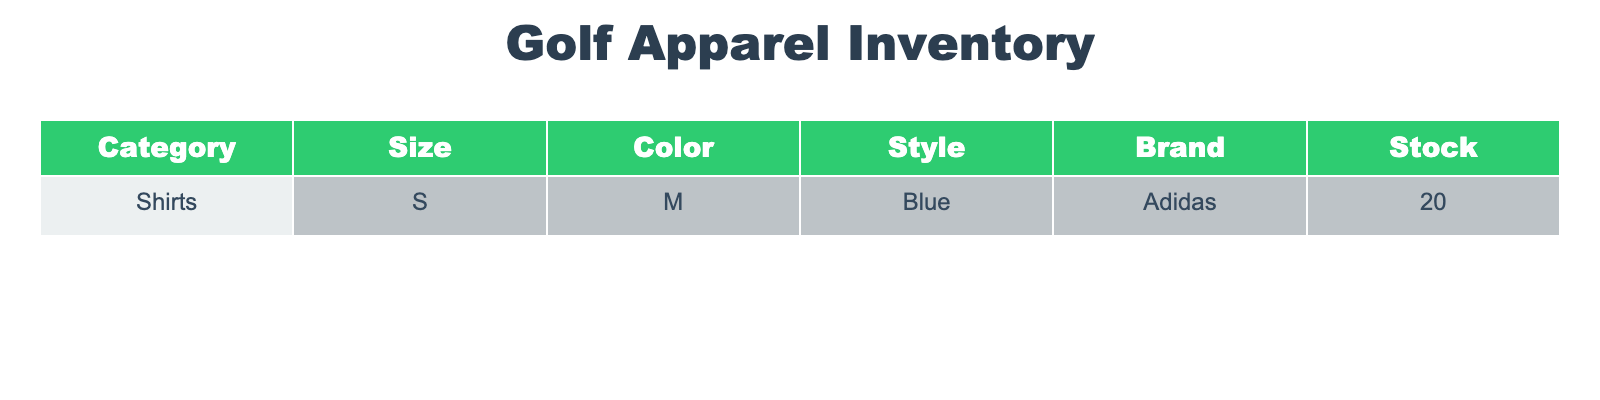What is the stock of blue shirts in size S? The table indicates that there are 20 blue shirts available in size S under the Adidas brand.
Answer: 20 How many different colors of shirts are listed in the inventory? The table shows only one color, which is blue, for the shirts listed. Therefore, there is just one color available.
Answer: 1 Is there any stock available for large size shirts? The table does not mention any large size shirts in the inventory. Since the only shirt listed is a size small, the answer is no.
Answer: No If two more stock items are added for the blue, size S shirt, what will the total stock be? The initial stock is 20. Adding 2 will result in 20 + 2 = 22. Therefore, the total stock after the addition will be 22.
Answer: 22 Are all the shirts in the inventory from the same brand? Yes, the table shows that all shirts listed belong to Adidas, indicating that there is no variation in brands.
Answer: Yes What is the total stock of shirts listed in the inventory? The total stock of shirts listed in the inventory is just 20, as there is only one item presented in the table.
Answer: 20 If the stock of blue shirts increases by 10, what will be the new stock value? The current stock is 20, so increasing it by 10 will give us a new value of 20 + 10 = 30. Therefore, the new stock value will be 30.
Answer: 30 Is there any stock of shirts available in size M or L? The provided data does not show any stock for sizes M or L; it only lists stock for size S. Thus, the answer is no.
Answer: No What brand has the highest stock in the table? The table only shows stock for one brand, Adidas. Therefore, it automatically has the highest stock, which is 20.
Answer: Adidas 